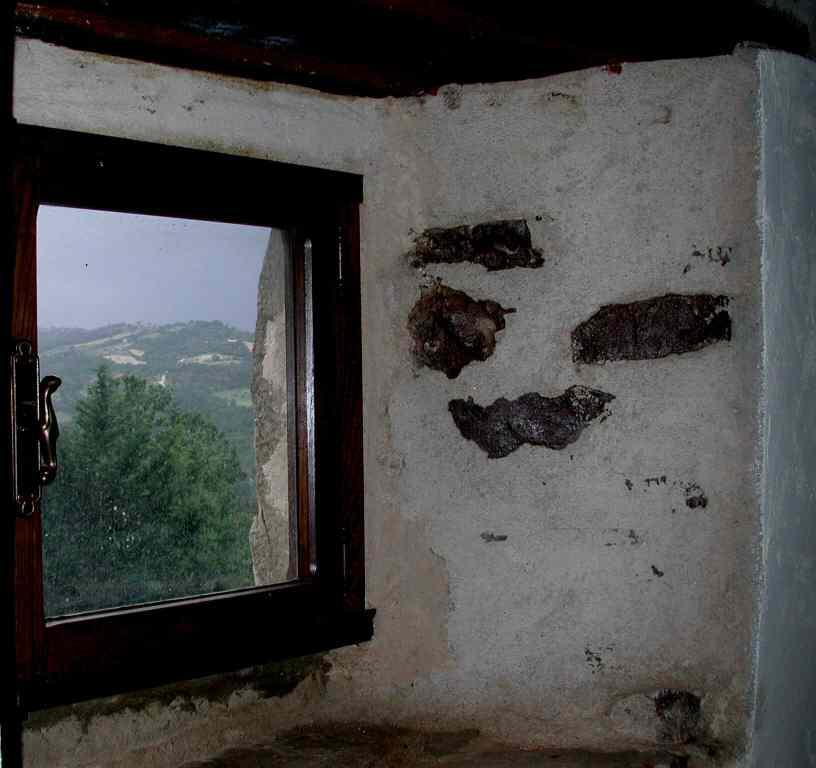What is the main feature of the wall in the image? There is a white wall in the image. What is located on the left side of the wall? There is a glass window on the left side of the image. What can be seen through the window? Trees, hills, and the sky are visible through the window. What type of work is being done on the white wall in the image? There is no indication of any work being done on the white wall in the image. Can you see the toes of the person standing near the window in the image? There is no person visible in the image, so it is impossible to see their toes. 